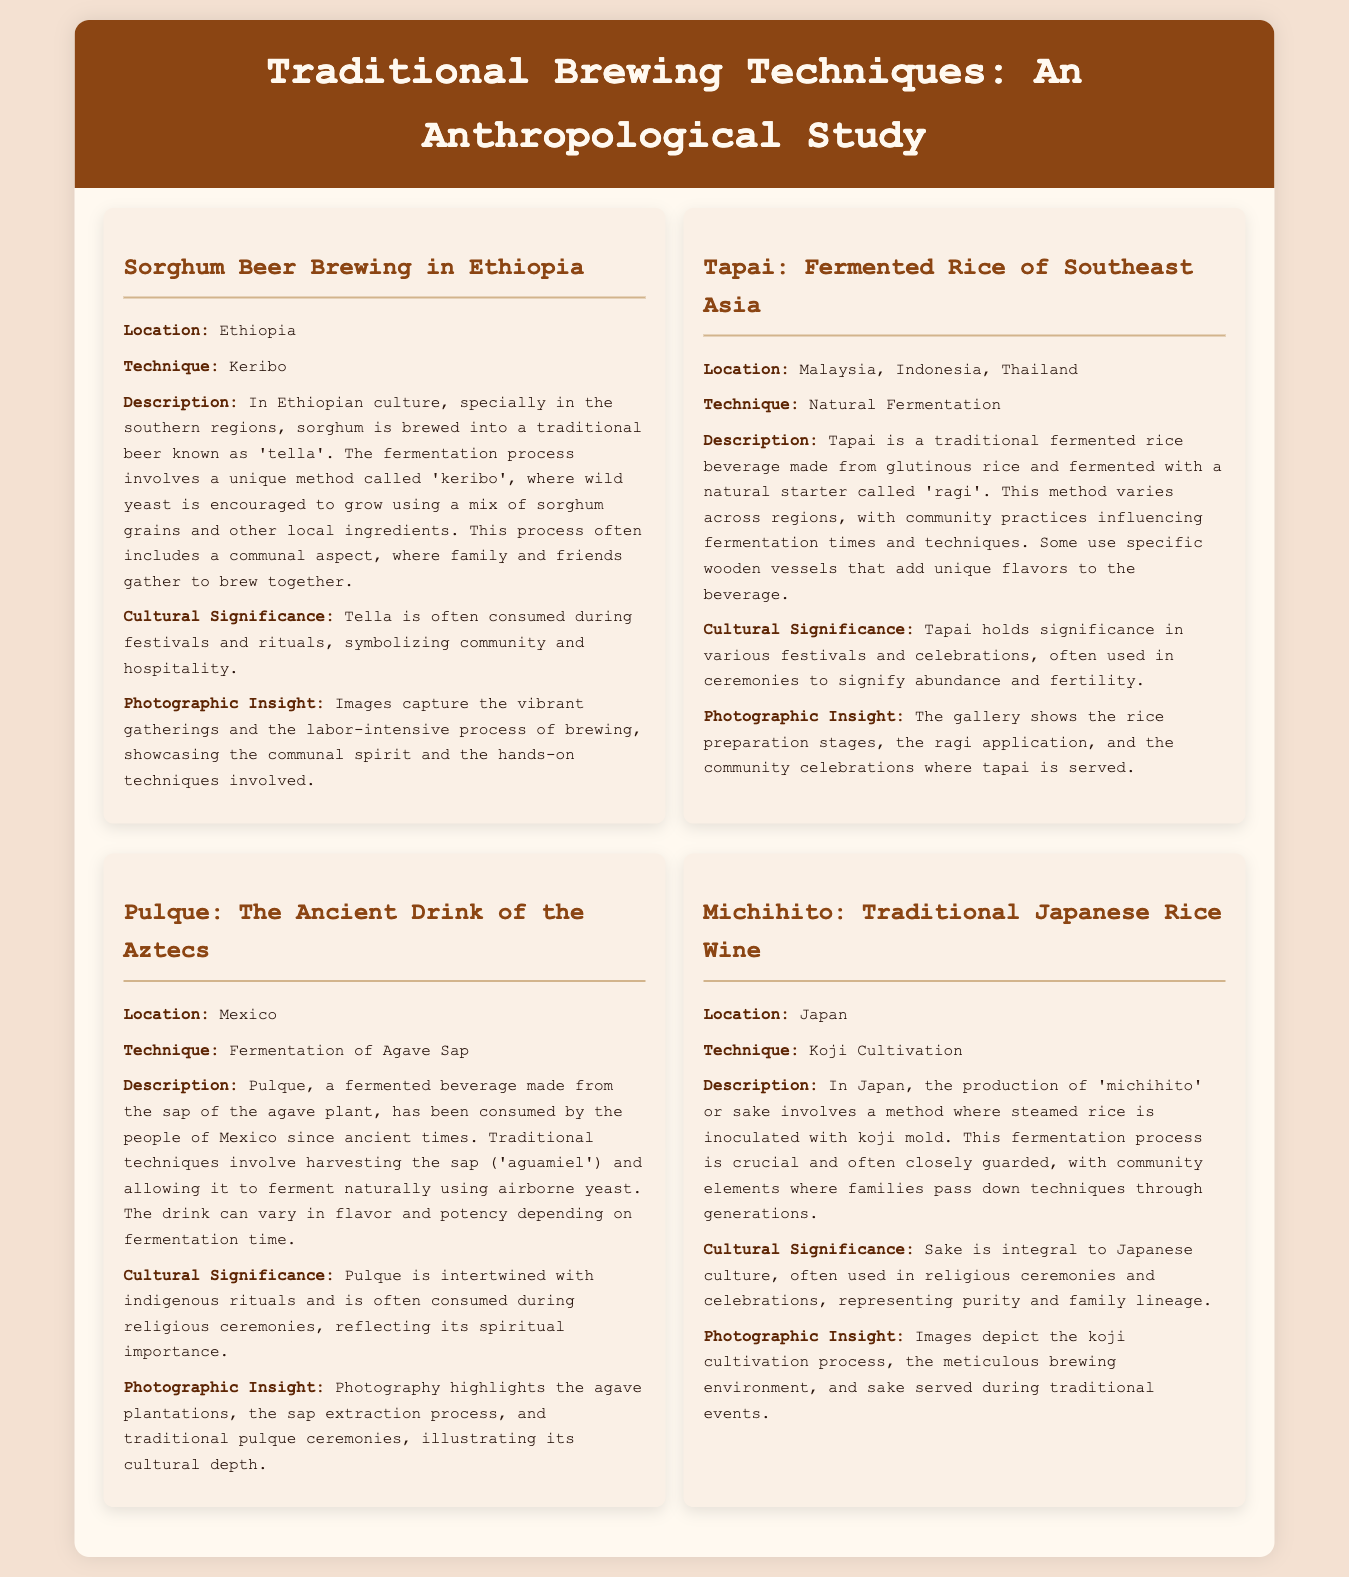What is the first technique mentioned in the document? The first technique listed is 'Keribo' used for brewing sorghum beer in Ethiopia.
Answer: Keribo Which country is associated with the production of Pulque? Pulque is a traditional drink that originates from Mexico.
Answer: Mexico What is tapai made from? Tapai is made from glutinous rice.
Answer: Glutinous rice What cultural role does tella play during occasions? Tella is consumed during festivals and rituals, symbolizing community and hospitality.
Answer: Festivals and rituals Which fermentation method is used in Japan for michihito? The method used is koji cultivation for the production of sake.
Answer: Koji Cultivation What ingredient is primarily fermented to produce Pulque? The primary ingredient fermented to produce Pulque is agave sap.
Answer: Agave Sap How is the creation of the rice beverage Tapai influenced? The fermentation times and techniques used to create Tapai are influenced by community practices.
Answer: Community practices What aspect of brewing does the photography in the document highlight? The photography highlights the communal spirit and the hands-on techniques involved in brewing.
Answer: Communal spirit and hands-on techniques 